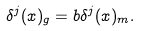Convert formula to latex. <formula><loc_0><loc_0><loc_500><loc_500>\delta ^ { j } ( x ) _ { g } = b \delta ^ { j } ( x ) _ { m } .</formula> 